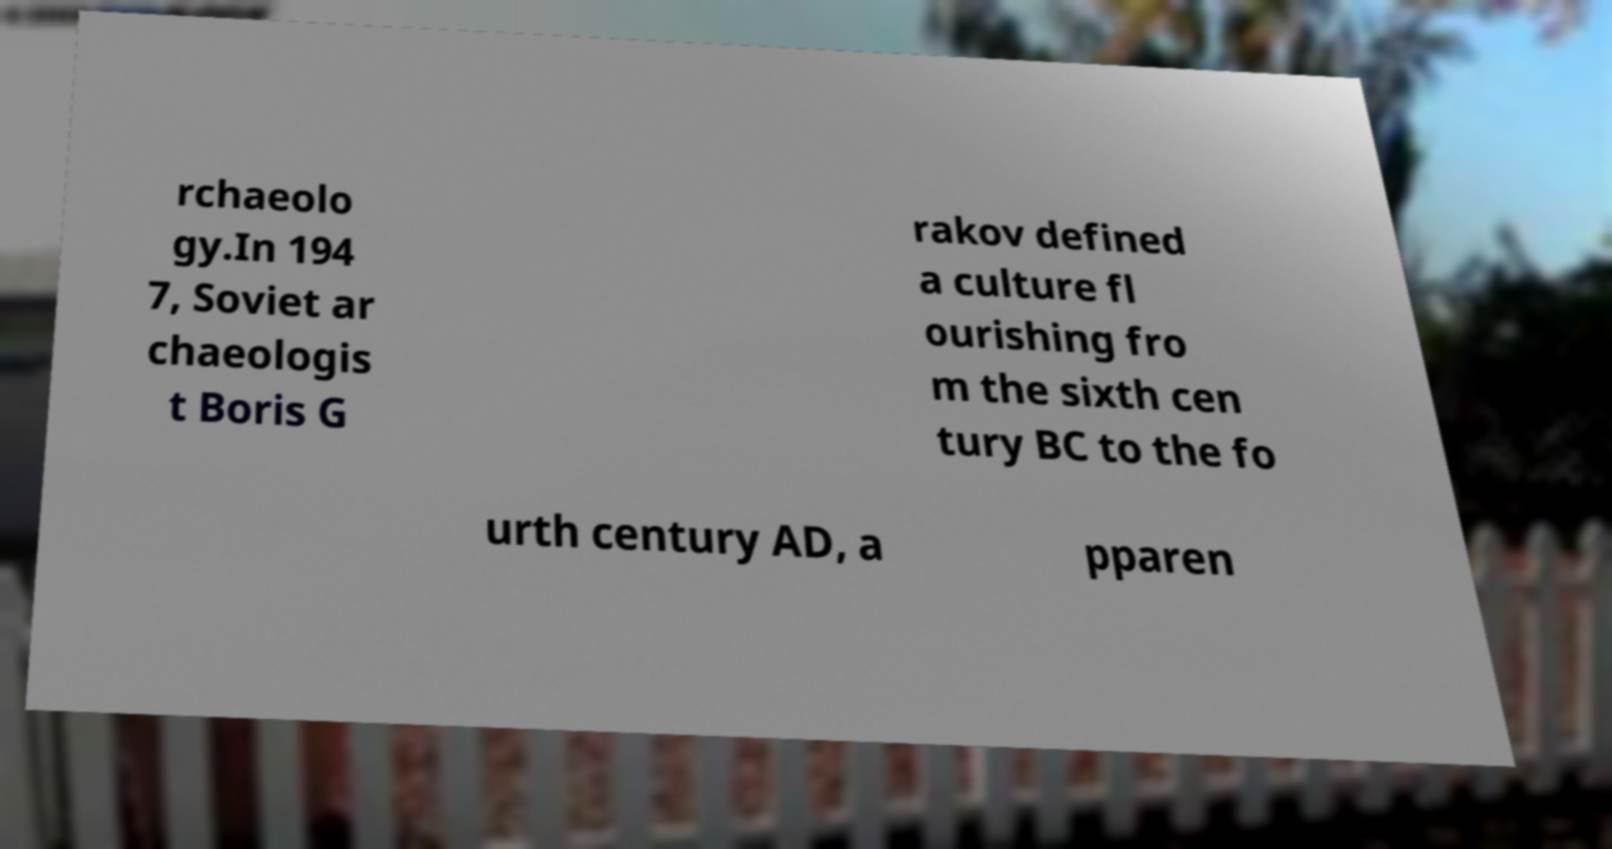Could you extract and type out the text from this image? rchaeolo gy.In 194 7, Soviet ar chaeologis t Boris G rakov defined a culture fl ourishing fro m the sixth cen tury BC to the fo urth century AD, a pparen 